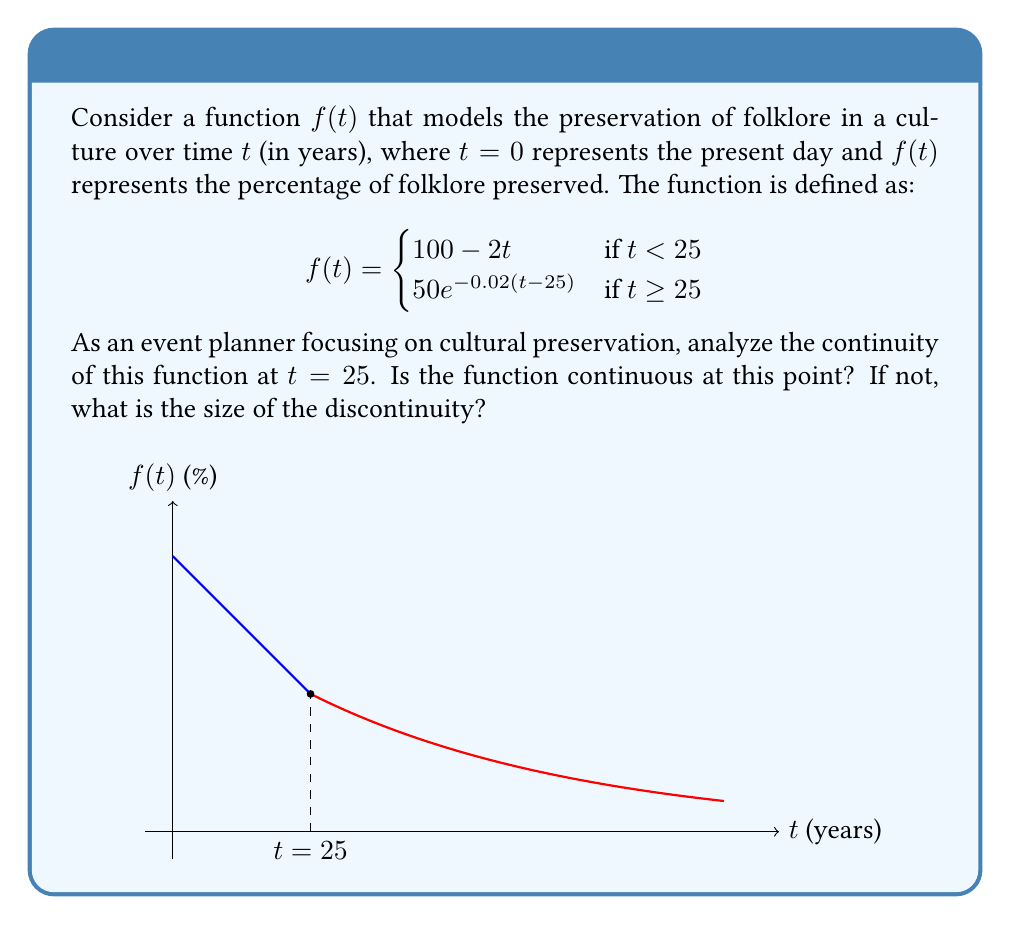Solve this math problem. To analyze the continuity of the function at $t=25$, we need to check if the limit of the function as $t$ approaches 25 from both sides exists and is equal to the function value at $t=25$. Let's follow these steps:

1) First, let's calculate the left-hand limit:
   $\lim_{t \to 25^-} f(t) = \lim_{t \to 25^-} (100 - 2t) = 100 - 2(25) = 50$

2) Now, let's calculate the right-hand limit:
   $\lim_{t \to 25^+} f(t) = \lim_{t \to 25^+} 50e^{-0.02(t-25)} = 50e^{-0.02(25-25)} = 50e^0 = 50$

3) Both left-hand and right-hand limits exist and are equal to 50.

4) Now, let's calculate the function value at $t=25$:
   $f(25) = 50e^{-0.02(25-25)} = 50e^0 = 50$

5) Since both limits and the function value at $t=25$ are all equal to 50, the function is continuous at $t=25$.

To visualize this, we can see from the graph that there is no jump or break in the function at $t=25$. The transition between the two pieces of the function is smooth, indicating continuity.
Answer: The function is continuous at $t=25$. 